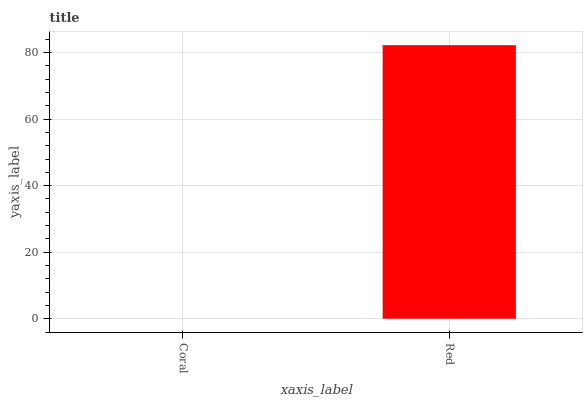Is Coral the minimum?
Answer yes or no. Yes. Is Red the maximum?
Answer yes or no. Yes. Is Red the minimum?
Answer yes or no. No. Is Red greater than Coral?
Answer yes or no. Yes. Is Coral less than Red?
Answer yes or no. Yes. Is Coral greater than Red?
Answer yes or no. No. Is Red less than Coral?
Answer yes or no. No. Is Red the high median?
Answer yes or no. Yes. Is Coral the low median?
Answer yes or no. Yes. Is Coral the high median?
Answer yes or no. No. Is Red the low median?
Answer yes or no. No. 